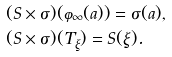<formula> <loc_0><loc_0><loc_500><loc_500>& ( S \times \sigma ) ( \varphi _ { \infty } ( a ) ) = \sigma ( a ) , \\ & ( S \times \sigma ) ( T _ { \xi } ) = S ( \xi ) .</formula> 